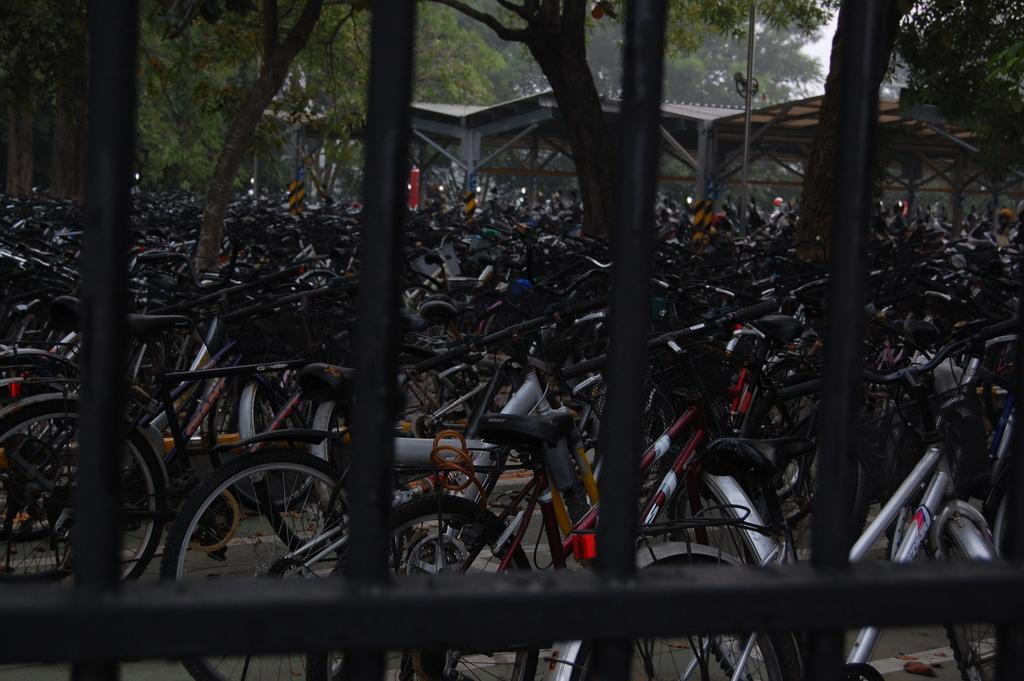What type of vehicles are in the image? There are cycles in the image. Where are the cycles located in relation to other objects? The cycles are beside trees. What structure can be seen at the top of the image? There is a shed at the top of the image. What type of pan is being used to sort the cycles in the image? There is no pan or sorting activity present in the image; it features cycles beside trees and a shed at the top. 